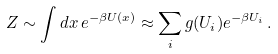Convert formula to latex. <formula><loc_0><loc_0><loc_500><loc_500>Z \sim \int d x \, e ^ { - \beta U ( x ) } \approx \sum _ { i } g ( U _ { i } ) e ^ { - \beta U _ { i } } \, .</formula> 